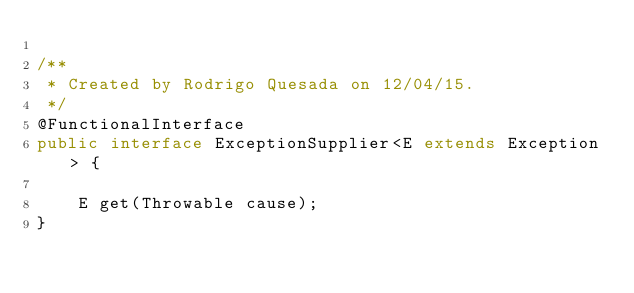Convert code to text. <code><loc_0><loc_0><loc_500><loc_500><_Java_>
/**
 * Created by Rodrigo Quesada on 12/04/15.
 */
@FunctionalInterface
public interface ExceptionSupplier<E extends Exception> {

    E get(Throwable cause);
}
</code> 